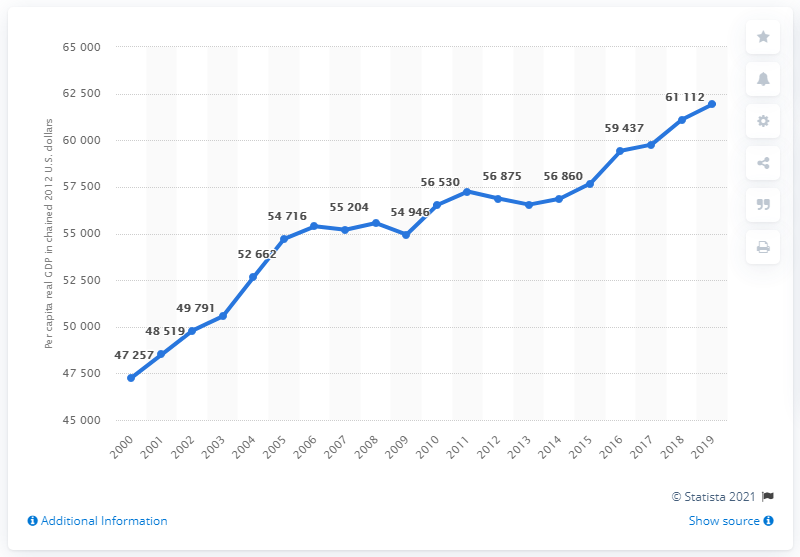Give some essential details in this illustration. In 2012, the per capita real GDP of Maryland was 61,926 chained. 